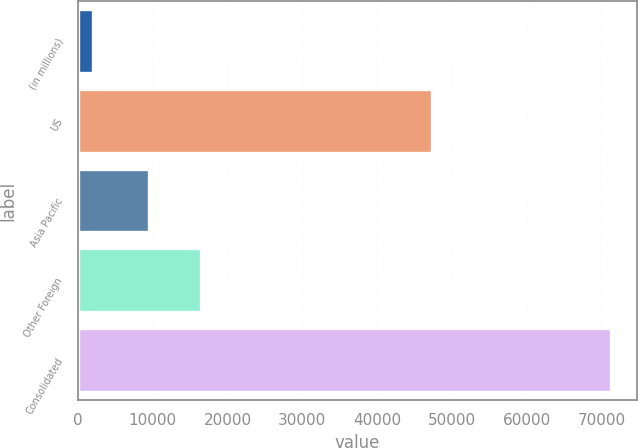Convert chart to OTSL. <chart><loc_0><loc_0><loc_500><loc_500><bar_chart><fcel>(in millions)<fcel>US<fcel>Asia Pacific<fcel>Other Foreign<fcel>Consolidated<nl><fcel>2012<fcel>47406<fcel>9498<fcel>16418.2<fcel>71214<nl></chart> 